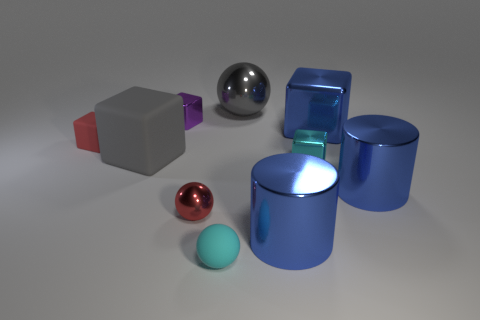Subtract all tiny cyan blocks. How many blocks are left? 4 Subtract 2 cubes. How many cubes are left? 3 Subtract all blue cubes. How many cubes are left? 4 Subtract all green cubes. Subtract all blue cylinders. How many cubes are left? 5 Subtract all balls. How many objects are left? 7 Add 2 tiny purple metallic cubes. How many tiny purple metallic cubes exist? 3 Subtract 0 gray cylinders. How many objects are left? 10 Subtract all spheres. Subtract all big green rubber cylinders. How many objects are left? 7 Add 2 small blocks. How many small blocks are left? 5 